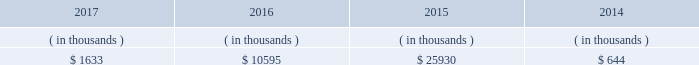Entergy mississippi may refinance , redeem , or otherwise retire debt and preferred stock prior to maturity , to the extent market conditions and interest and dividend rates are favorable .
All debt and common and preferred stock issuances by entergy mississippi require prior regulatory approval . a0 a0preferred stock and debt issuances are also subject to issuance tests set forth in its corporate charter , bond indenture , and other agreements . a0 a0entergy mississippi has sufficient capacity under these tests to meet its foreseeable capital needs .
Entergy mississippi 2019s receivables from the money pool were as follows as of december 31 for each of the following years. .
See note 4 to the financial statements for a description of the money pool .
Entergy mississippi has four separate credit facilities in the aggregate amount of $ 102.5 million scheduled to expire may 2018 .
No borrowings were outstanding under the credit facilities as of december a031 , 2017 . a0 a0in addition , entergy mississippi is a party to an uncommitted letter of credit facility as a means to post collateral to support its obligations to miso .
As of december a031 , 2017 , a $ 15.3 million letter of credit was outstanding under entergy mississippi 2019s uncommitted letter of credit facility .
See note 4 to the financial statements for additional discussion of the credit facilities .
Entergy mississippi obtained authorizations from the ferc through october 2019 for short-term borrowings not to exceed an aggregate amount of $ 175 million at any time outstanding and long-term borrowings and security issuances .
See note 4 to the financial statements for further discussion of entergy mississippi 2019s short-term borrowing limits .
Entergy mississippi , inc .
Management 2019s financial discussion and analysis state and local rate regulation and fuel-cost recovery the rates that entergy mississippi charges for electricity significantly influence its financial position , results of operations , and liquidity .
Entergy mississippi is regulated and the rates charged to its customers are determined in regulatory proceedings .
A governmental agency , the mpsc , is primarily responsible for approval of the rates charged to customers .
Formula rate plan in march 2016 , entergy mississippi submitted its formula rate plan 2016 test year filing showing entergy mississippi 2019s projected earned return for the 2016 calendar year to be below the formula rate plan bandwidth .
The filing showed a $ 32.6 million rate increase was necessary to reset entergy mississippi 2019s earned return on common equity to the specified point of adjustment of 9.96% ( 9.96 % ) , within the formula rate plan bandwidth .
In june 2016 the mpsc approved entergy mississippi 2019s joint stipulation with the mississippi public utilities staff .
The joint stipulation provided for a total revenue increase of $ 23.7 million .
The revenue increase includes a $ 19.4 million increase through the formula rate plan , resulting in a return on common equity point of adjustment of 10.07% ( 10.07 % ) .
The revenue increase also includes $ 4.3 million in incremental ad valorem tax expenses to be collected through an updated ad valorem tax adjustment rider .
The revenue increase and ad valorem tax adjustment rider were effective with the july 2016 bills .
In march 2017 , entergy mississippi submitted its formula rate plan 2017 test year filing and 2016 look-back filing showing entergy mississippi 2019s earned return for the historical 2016 calendar year and projected earned return for the 2017 calendar year to be within the formula rate plan bandwidth , resulting in no change in rates .
In june 2017 , entergy mississippi and the mississippi public utilities staff entered into a stipulation that confirmed that entergy .
Not including letters from the uncommitted facility , what percent of the borrowings allowance do the letters of credits set to expire may 2018 amount to? 
Computations: (102.5 / 175)
Answer: 0.58571. 